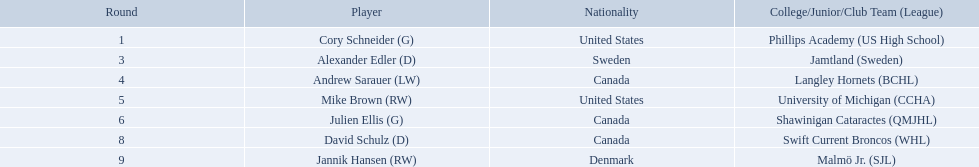What are the nationalities of the players? United States, Sweden, Canada, United States, Canada, Canada, Denmark. I'm looking to parse the entire table for insights. Could you assist me with that? {'header': ['Round', 'Player', 'Nationality', 'College/Junior/Club Team (League)'], 'rows': [['1', 'Cory Schneider (G)', 'United States', 'Phillips Academy (US High School)'], ['3', 'Alexander Edler (D)', 'Sweden', 'Jamtland (Sweden)'], ['4', 'Andrew Sarauer (LW)', 'Canada', 'Langley Hornets (BCHL)'], ['5', 'Mike Brown (RW)', 'United States', 'University of Michigan (CCHA)'], ['6', 'Julien Ellis (G)', 'Canada', 'Shawinigan Cataractes (QMJHL)'], ['8', 'David Schulz (D)', 'Canada', 'Swift Current Broncos (WHL)'], ['9', 'Jannik Hansen (RW)', 'Denmark', 'Malmö Jr. (SJL)']]} Of the players, which one lists his nationality as denmark? Jannik Hansen (RW). Who are the players? Cory Schneider (G), Alexander Edler (D), Andrew Sarauer (LW), Mike Brown (RW), Julien Ellis (G), David Schulz (D), Jannik Hansen (RW). Of those, who is from denmark? Jannik Hansen (RW). Give me the full table as a dictionary. {'header': ['Round', 'Player', 'Nationality', 'College/Junior/Club Team (League)'], 'rows': [['1', 'Cory Schneider (G)', 'United States', 'Phillips Academy (US High School)'], ['3', 'Alexander Edler (D)', 'Sweden', 'Jamtland (Sweden)'], ['4', 'Andrew Sarauer (LW)', 'Canada', 'Langley Hornets (BCHL)'], ['5', 'Mike Brown (RW)', 'United States', 'University of Michigan (CCHA)'], ['6', 'Julien Ellis (G)', 'Canada', 'Shawinigan Cataractes (QMJHL)'], ['8', 'David Schulz (D)', 'Canada', 'Swift Current Broncos (WHL)'], ['9', 'Jannik Hansen (RW)', 'Denmark', 'Malmö Jr. (SJL)']]} Parse the full table. {'header': ['Round', 'Player', 'Nationality', 'College/Junior/Club Team (League)'], 'rows': [['1', 'Cory Schneider (G)', 'United States', 'Phillips Academy (US High School)'], ['3', 'Alexander Edler (D)', 'Sweden', 'Jamtland (Sweden)'], ['4', 'Andrew Sarauer (LW)', 'Canada', 'Langley Hornets (BCHL)'], ['5', 'Mike Brown (RW)', 'United States', 'University of Michigan (CCHA)'], ['6', 'Julien Ellis (G)', 'Canada', 'Shawinigan Cataractes (QMJHL)'], ['8', 'David Schulz (D)', 'Canada', 'Swift Current Broncos (WHL)'], ['9', 'Jannik Hansen (RW)', 'Denmark', 'Malmö Jr. (SJL)']]} Who were the players in the 2004-05 vancouver canucks season Cory Schneider (G), Alexander Edler (D), Andrew Sarauer (LW), Mike Brown (RW), Julien Ellis (G), David Schulz (D), Jannik Hansen (RW). Of these players who had a nationality of denmark? Jannik Hansen (RW). Who are all the players? Cory Schneider (G), Alexander Edler (D), Andrew Sarauer (LW), Mike Brown (RW), Julien Ellis (G), David Schulz (D), Jannik Hansen (RW). What is the nationality of each player? United States, Sweden, Canada, United States, Canada, Canada, Denmark. Where did they attend school? Phillips Academy (US High School), Jamtland (Sweden), Langley Hornets (BCHL), University of Michigan (CCHA), Shawinigan Cataractes (QMJHL), Swift Current Broncos (WHL), Malmö Jr. (SJL). Which player attended langley hornets? Andrew Sarauer (LW). Which players have canadian nationality? Andrew Sarauer (LW), Julien Ellis (G), David Schulz (D). Of those, which attended langley hornets? Andrew Sarauer (LW). 